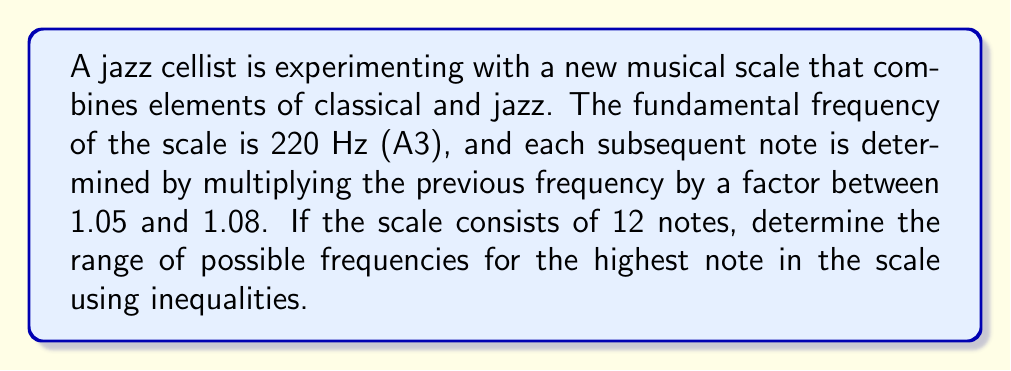Can you solve this math problem? Let's approach this step-by-step:

1) The fundamental frequency is 220 Hz. Let's call this $f_0$.

2) Each subsequent frequency is found by multiplying the previous one by a factor between 1.05 and 1.08. We can express this as:

   $1.05 \leq \frac{f_{n+1}}{f_n} \leq 1.08$

3) For the 12th note (the highest in the scale), we need to apply this factor 11 times. We can express this as:

   $220 \cdot 1.05^{11} \leq f_{12} \leq 220 \cdot 1.08^{11}$

4) Let's calculate the lower bound:
   $220 \cdot 1.05^{11} \approx 375.28$ Hz

5) Now the upper bound:
   $220 \cdot 1.08^{11} \approx 506.03$ Hz

6) Therefore, we can express the range of the highest note as:

   $375.28 \leq f_{12} \leq 506.03$

This inequality represents the range of possible frequencies for the highest note in the scale.
Answer: $375.28 \leq f_{12} \leq 506.03$ 